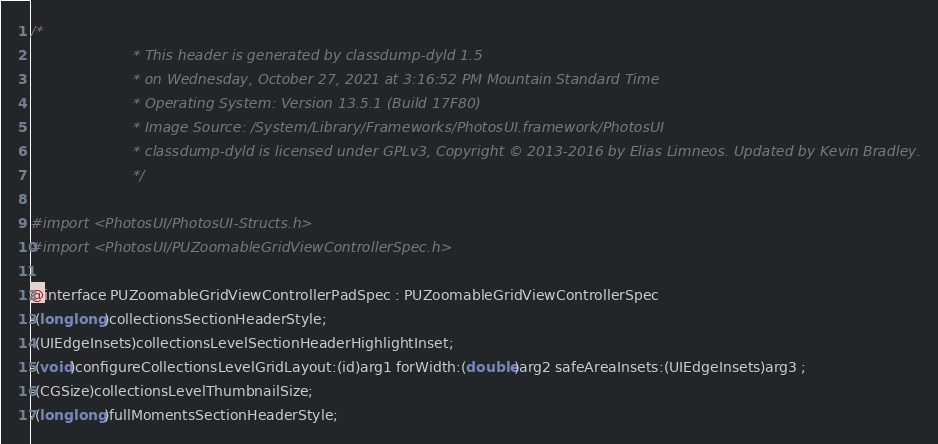Convert code to text. <code><loc_0><loc_0><loc_500><loc_500><_C_>/*
                       * This header is generated by classdump-dyld 1.5
                       * on Wednesday, October 27, 2021 at 3:16:52 PM Mountain Standard Time
                       * Operating System: Version 13.5.1 (Build 17F80)
                       * Image Source: /System/Library/Frameworks/PhotosUI.framework/PhotosUI
                       * classdump-dyld is licensed under GPLv3, Copyright © 2013-2016 by Elias Limneos. Updated by Kevin Bradley.
                       */

#import <PhotosUI/PhotosUI-Structs.h>
#import <PhotosUI/PUZoomableGridViewControllerSpec.h>

@interface PUZoomableGridViewControllerPadSpec : PUZoomableGridViewControllerSpec
-(long long)collectionsSectionHeaderStyle;
-(UIEdgeInsets)collectionsLevelSectionHeaderHighlightInset;
-(void)configureCollectionsLevelGridLayout:(id)arg1 forWidth:(double)arg2 safeAreaInsets:(UIEdgeInsets)arg3 ;
-(CGSize)collectionsLevelThumbnailSize;
-(long long)fullMomentsSectionHeaderStyle;</code> 